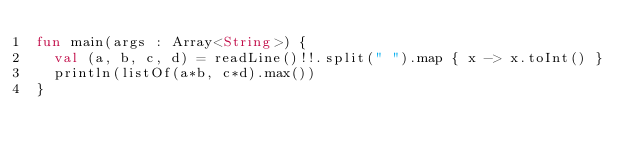Convert code to text. <code><loc_0><loc_0><loc_500><loc_500><_Kotlin_>fun main(args : Array<String>) { 
  val (a, b, c, d) = readLine()!!.split(" ").map { x -> x.toInt() }
  println(listOf(a*b, c*d).max())
}
</code> 